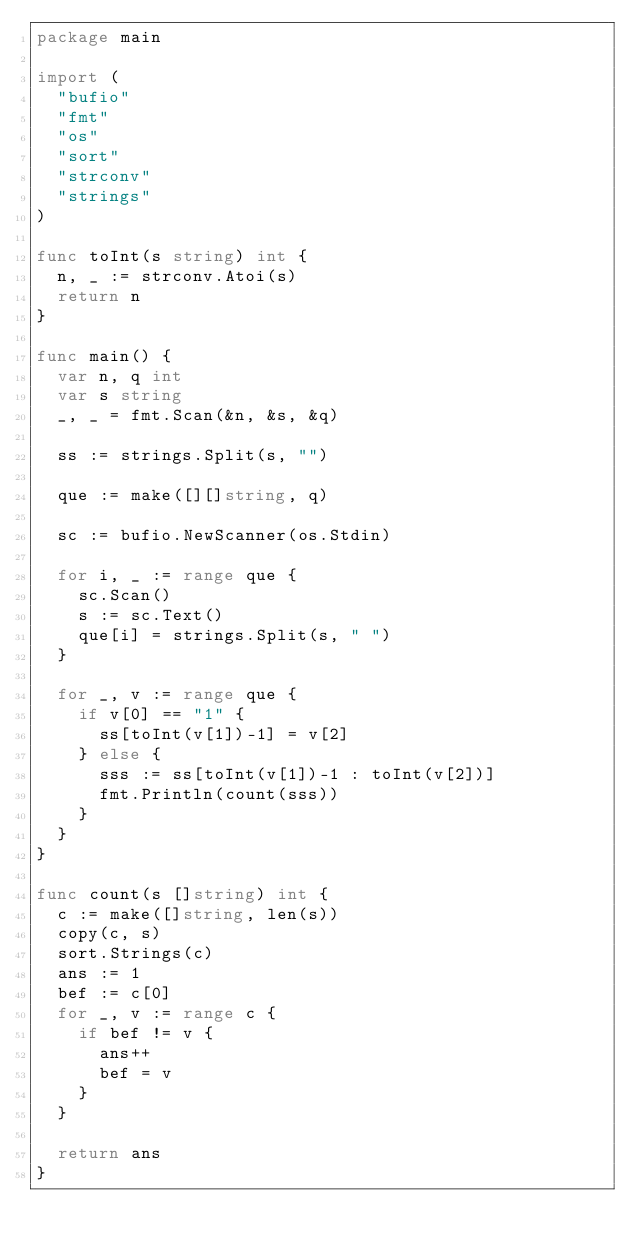Convert code to text. <code><loc_0><loc_0><loc_500><loc_500><_Go_>package main

import (
	"bufio"
	"fmt"
	"os"
	"sort"
	"strconv"
	"strings"
)

func toInt(s string) int {
	n, _ := strconv.Atoi(s)
	return n
}

func main() {
	var n, q int
	var s string
	_, _ = fmt.Scan(&n, &s, &q)
	
	ss := strings.Split(s, "")
	
	que := make([][]string, q)
	
	sc := bufio.NewScanner(os.Stdin)
	
	for i, _ := range que {
		sc.Scan()
		s := sc.Text()
		que[i] = strings.Split(s, " ")
	}
	
	for _, v := range que {
		if v[0] == "1" {
			ss[toInt(v[1])-1] = v[2]
		} else {
			sss := ss[toInt(v[1])-1 : toInt(v[2])]
			fmt.Println(count(sss))
		}
	}
}

func count(s []string) int {
	c := make([]string, len(s))
	copy(c, s)
	sort.Strings(c)
	ans := 1
	bef := c[0]
	for _, v := range c {
		if bef != v {
			ans++
			bef = v
		}
	}
	
	return ans
}
</code> 